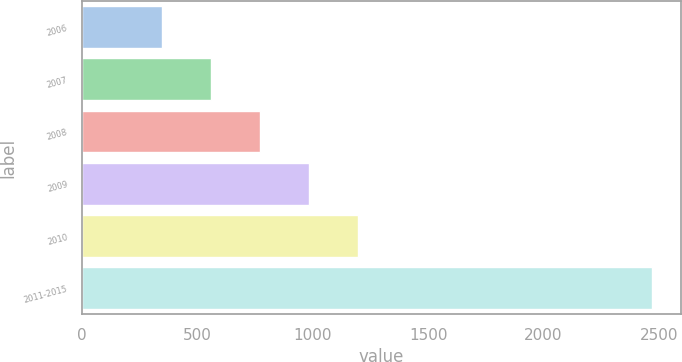Convert chart to OTSL. <chart><loc_0><loc_0><loc_500><loc_500><bar_chart><fcel>2006<fcel>2007<fcel>2008<fcel>2009<fcel>2010<fcel>2011-2015<nl><fcel>348<fcel>560.2<fcel>772.4<fcel>984.6<fcel>1196.8<fcel>2470<nl></chart> 